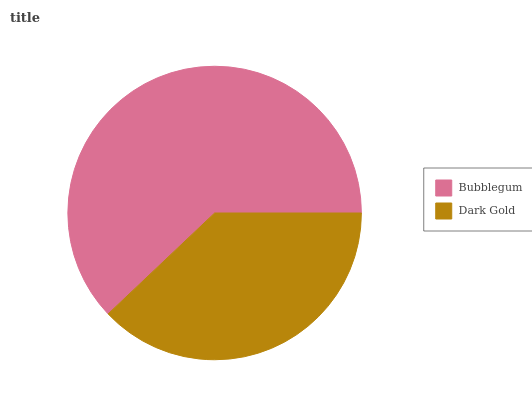Is Dark Gold the minimum?
Answer yes or no. Yes. Is Bubblegum the maximum?
Answer yes or no. Yes. Is Dark Gold the maximum?
Answer yes or no. No. Is Bubblegum greater than Dark Gold?
Answer yes or no. Yes. Is Dark Gold less than Bubblegum?
Answer yes or no. Yes. Is Dark Gold greater than Bubblegum?
Answer yes or no. No. Is Bubblegum less than Dark Gold?
Answer yes or no. No. Is Bubblegum the high median?
Answer yes or no. Yes. Is Dark Gold the low median?
Answer yes or no. Yes. Is Dark Gold the high median?
Answer yes or no. No. Is Bubblegum the low median?
Answer yes or no. No. 